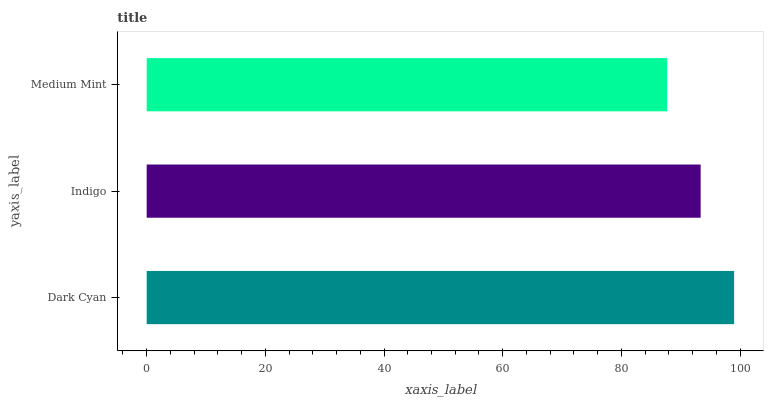Is Medium Mint the minimum?
Answer yes or no. Yes. Is Dark Cyan the maximum?
Answer yes or no. Yes. Is Indigo the minimum?
Answer yes or no. No. Is Indigo the maximum?
Answer yes or no. No. Is Dark Cyan greater than Indigo?
Answer yes or no. Yes. Is Indigo less than Dark Cyan?
Answer yes or no. Yes. Is Indigo greater than Dark Cyan?
Answer yes or no. No. Is Dark Cyan less than Indigo?
Answer yes or no. No. Is Indigo the high median?
Answer yes or no. Yes. Is Indigo the low median?
Answer yes or no. Yes. Is Dark Cyan the high median?
Answer yes or no. No. Is Dark Cyan the low median?
Answer yes or no. No. 